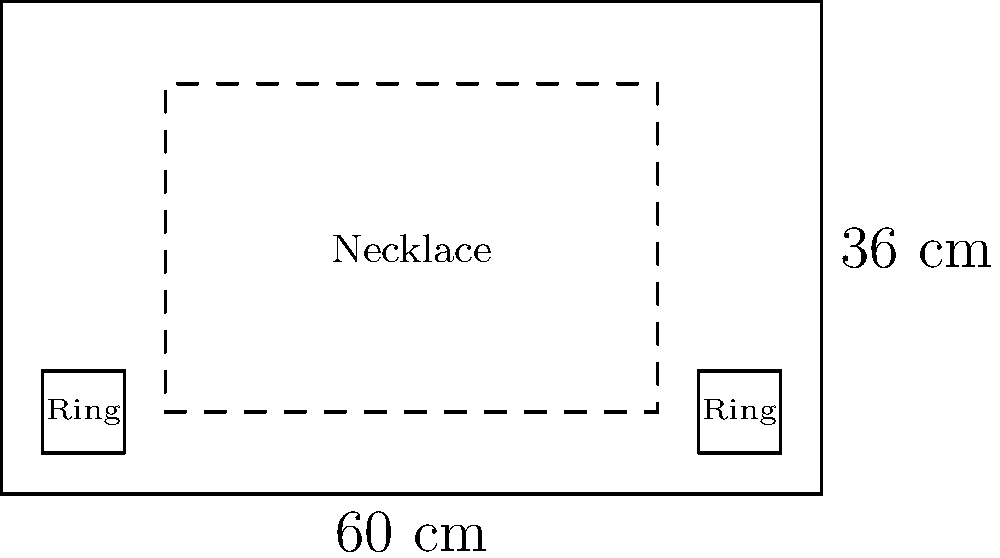As a jewelry brand owner, you're planning a new display for your showcase. The showcase measures 60 cm in width and 36 cm in height. You want to display necklaces in the center, occupying a space of 48 cm × 24 cm, with rings displayed on either side. If each ring display measures 6 cm × 6 cm, what is the maximum number of ring displays that can fit on both sides of the necklace display? Express your answer as a function of $x$, where $x$ represents the space (in cm) between each ring display and between the ring displays and the showcase edges. Let's approach this step-by-step:

1) First, we need to calculate the available width for ring displays:
   Total width - Necklace width = $60 \text{ cm} - 48 \text{ cm} = 12 \text{ cm}$

2) This 12 cm is split equally on both sides, so we have 6 cm on each side for ring displays.

3) Now, let's consider one side. We need to fit as many 6 cm ring displays as possible, with $x$ cm spacing between them and at the edges.

4) The number of spaces will always be one more than the number of ring displays. If we have $n$ ring displays on one side, we'll have $n+1$ spaces.

5) We can express this as an equation:
   $6n + x(n+1) = 6$
   Where $6n$ is the total width of the ring displays, and $x(n+1)$ is the total width of the spaces.

6) Solving for $n$:
   $6n + xn + x = 6$
   $n(6+x) + x = 6$
   $n(6+x) = 6-x$
   $n = \frac{6-x}{6+x}$

7) Since we want the maximum number of displays, we need to round down this value (as we can't have a fraction of a display). We also need to multiply by 2 since this is for both sides.

8) Therefore, the function for the maximum number of ring displays is:
   $f(x) = 2 \cdot \left\lfloor\frac{6-x}{6+x}\right\rfloor$

Where $\lfloor \rfloor$ represents the floor function (rounding down to the nearest integer).
Answer: $f(x) = 2 \cdot \left\lfloor\frac{6-x}{6+x}\right\rfloor$ 